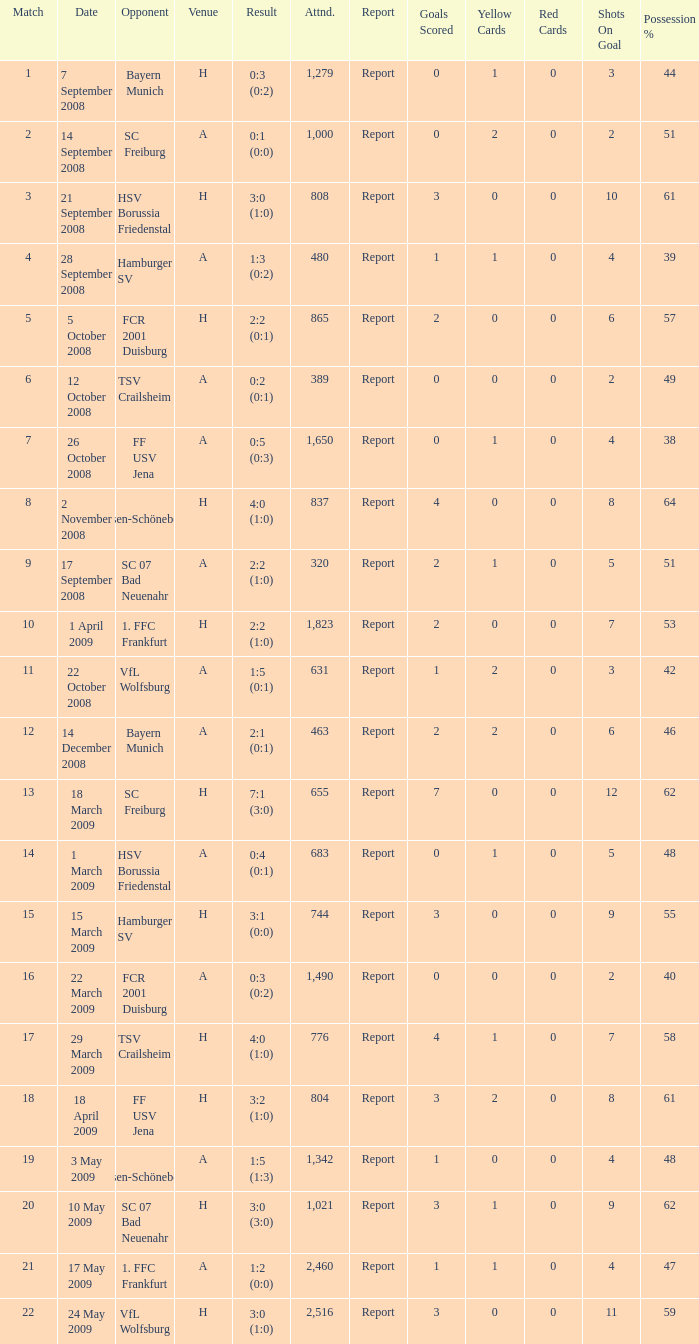What is the match number that had a result of 0:5 (0:3)? 1.0. Write the full table. {'header': ['Match', 'Date', 'Opponent', 'Venue', 'Result', 'Attnd.', 'Report', 'Goals Scored', 'Yellow Cards', 'Red Cards', 'Shots On Goal', 'Possession %'], 'rows': [['1', '7 September 2008', 'Bayern Munich', 'H', '0:3 (0:2)', '1,279', 'Report', '0', '1', '0', '3', '44'], ['2', '14 September 2008', 'SC Freiburg', 'A', '0:1 (0:0)', '1,000', 'Report', '0', '2', '0', '2', '51'], ['3', '21 September 2008', 'HSV Borussia Friedenstal', 'H', '3:0 (1:0)', '808', 'Report', '3', '0', '0', '10', '61'], ['4', '28 September 2008', 'Hamburger SV', 'A', '1:3 (0:2)', '480', 'Report', '1', '1', '0', '4', '39'], ['5', '5 October 2008', 'FCR 2001 Duisburg', 'H', '2:2 (0:1)', '865', 'Report', '2', '0', '0', '6', '57'], ['6', '12 October 2008', 'TSV Crailsheim', 'A', '0:2 (0:1)', '389', 'Report', '0', '0', '0', '2', '49'], ['7', '26 October 2008', 'FF USV Jena', 'A', '0:5 (0:3)', '1,650', 'Report', '0', '1', '0', '4', '38'], ['8', '2 November 2008', 'SG Essen-Schönebeck', 'H', '4:0 (1:0)', '837', 'Report', '4', '0', '0', '8', '64'], ['9', '17 September 2008', 'SC 07 Bad Neuenahr', 'A', '2:2 (1:0)', '320', 'Report', '2', '1', '0', '5', '51'], ['10', '1 April 2009', '1. FFC Frankfurt', 'H', '2:2 (1:0)', '1,823', 'Report', '2', '0', '0', '7', '53'], ['11', '22 October 2008', 'VfL Wolfsburg', 'A', '1:5 (0:1)', '631', 'Report', '1', '2', '0', '3', '42'], ['12', '14 December 2008', 'Bayern Munich', 'A', '2:1 (0:1)', '463', 'Report', '2', '2', '0', '6', '46'], ['13', '18 March 2009', 'SC Freiburg', 'H', '7:1 (3:0)', '655', 'Report', '7', '0', '0', '12', '62'], ['14', '1 March 2009', 'HSV Borussia Friedenstal', 'A', '0:4 (0:1)', '683', 'Report', '0', '1', '0', '5', '48'], ['15', '15 March 2009', 'Hamburger SV', 'H', '3:1 (0:0)', '744', 'Report', '3', '0', '0', '9', '55'], ['16', '22 March 2009', 'FCR 2001 Duisburg', 'A', '0:3 (0:2)', '1,490', 'Report', '0', '0', '0', '2', '40'], ['17', '29 March 2009', 'TSV Crailsheim', 'H', '4:0 (1:0)', '776', 'Report', '4', '1', '0', '7', '58'], ['18', '18 April 2009', 'FF USV Jena', 'H', '3:2 (1:0)', '804', 'Report', '3', '2', '0', '8', '61'], ['19', '3 May 2009', 'SG Essen-Schönebeck', 'A', '1:5 (1:3)', '1,342', 'Report', '1', '0', '0', '4', '48'], ['20', '10 May 2009', 'SC 07 Bad Neuenahr', 'H', '3:0 (3:0)', '1,021', 'Report', '3', '1', '0', '9', '62'], ['21', '17 May 2009', '1. FFC Frankfurt', 'A', '1:2 (0:0)', '2,460', 'Report', '1', '1', '0', '4', '47'], ['22', '24 May 2009', 'VfL Wolfsburg', 'H', '3:0 (1:0)', '2,516', 'Report', '3', '0', '0', '11', '59']]} 